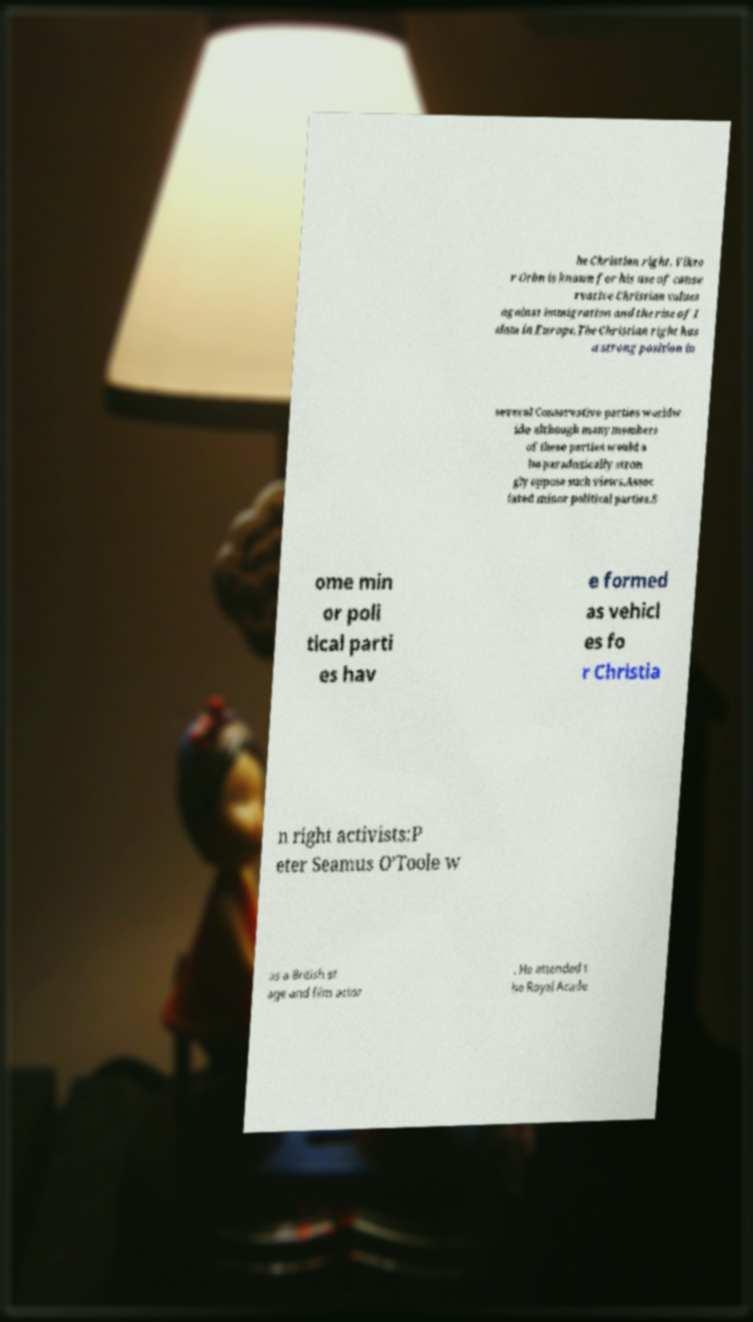Please identify and transcribe the text found in this image. he Christian right. Vikto r Orbn is known for his use of conse rvative Christian values against immigration and the rise of I slam in Europe.The Christian right has a strong position in several Conservative parties worldw ide although many members of these parties would a lso paradoxically stron gly oppose such views.Assoc iated minor political parties.S ome min or poli tical parti es hav e formed as vehicl es fo r Christia n right activists:P eter Seamus O'Toole w as a British st age and film actor . He attended t he Royal Acade 